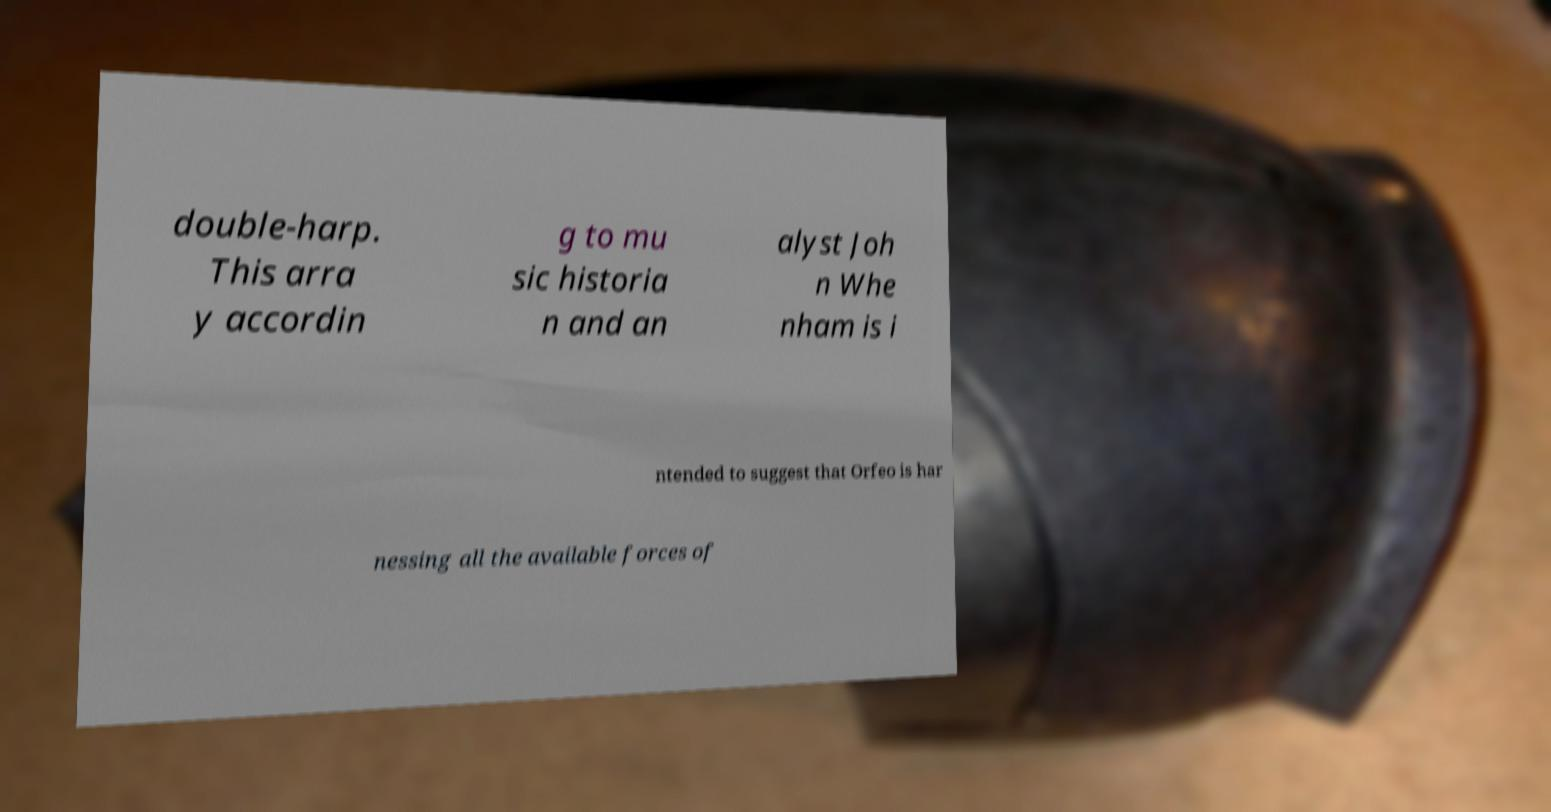Please read and relay the text visible in this image. What does it say? double-harp. This arra y accordin g to mu sic historia n and an alyst Joh n Whe nham is i ntended to suggest that Orfeo is har nessing all the available forces of 